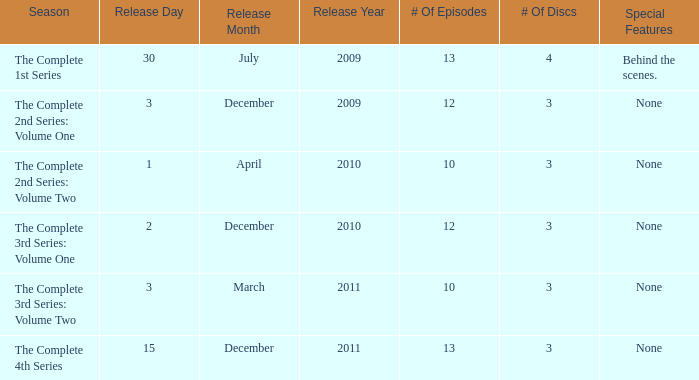On how many dates was the complete 4th series released? 1.0. 